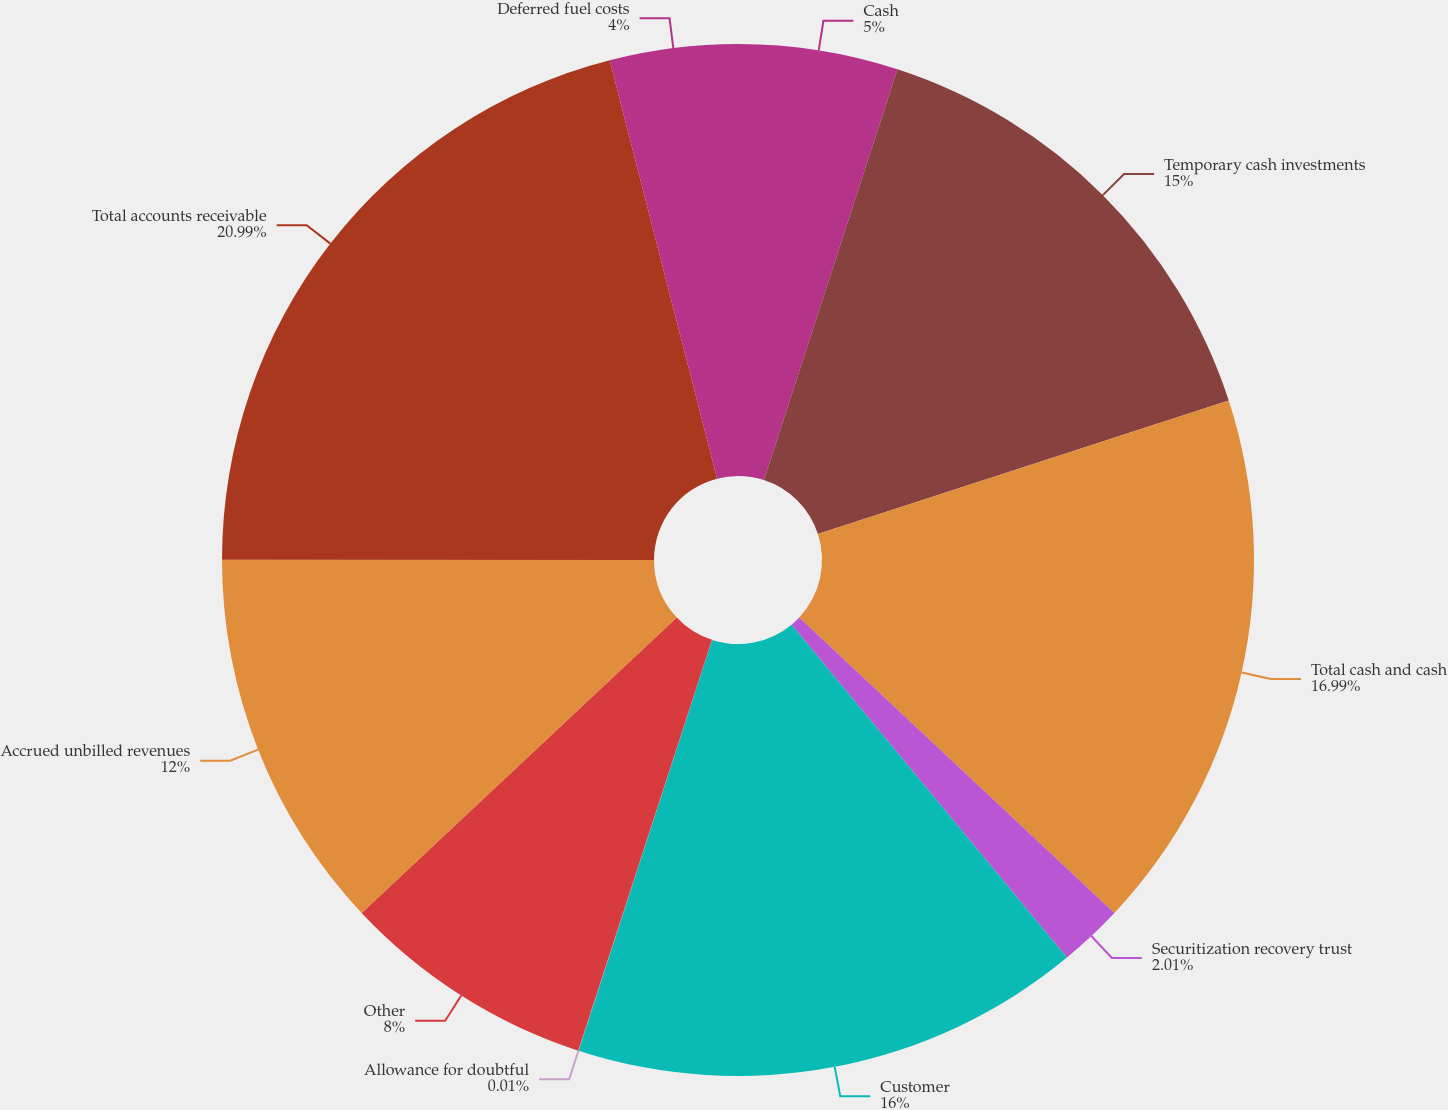<chart> <loc_0><loc_0><loc_500><loc_500><pie_chart><fcel>Cash<fcel>Temporary cash investments<fcel>Total cash and cash<fcel>Securitization recovery trust<fcel>Customer<fcel>Allowance for doubtful<fcel>Other<fcel>Accrued unbilled revenues<fcel>Total accounts receivable<fcel>Deferred fuel costs<nl><fcel>5.0%<fcel>15.0%<fcel>16.99%<fcel>2.01%<fcel>16.0%<fcel>0.01%<fcel>8.0%<fcel>12.0%<fcel>20.99%<fcel>4.0%<nl></chart> 